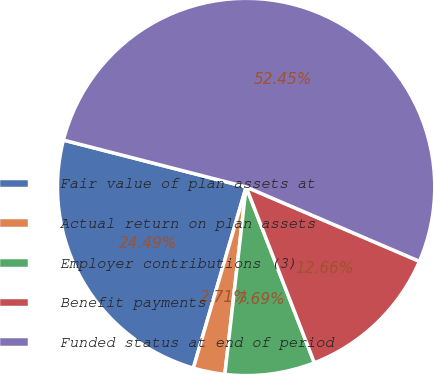Convert chart to OTSL. <chart><loc_0><loc_0><loc_500><loc_500><pie_chart><fcel>Fair value of plan assets at<fcel>Actual return on plan assets<fcel>Employer contributions (3)<fcel>Benefit payments<fcel>Funded status at end of period<nl><fcel>24.49%<fcel>2.71%<fcel>7.69%<fcel>12.66%<fcel>52.45%<nl></chart> 